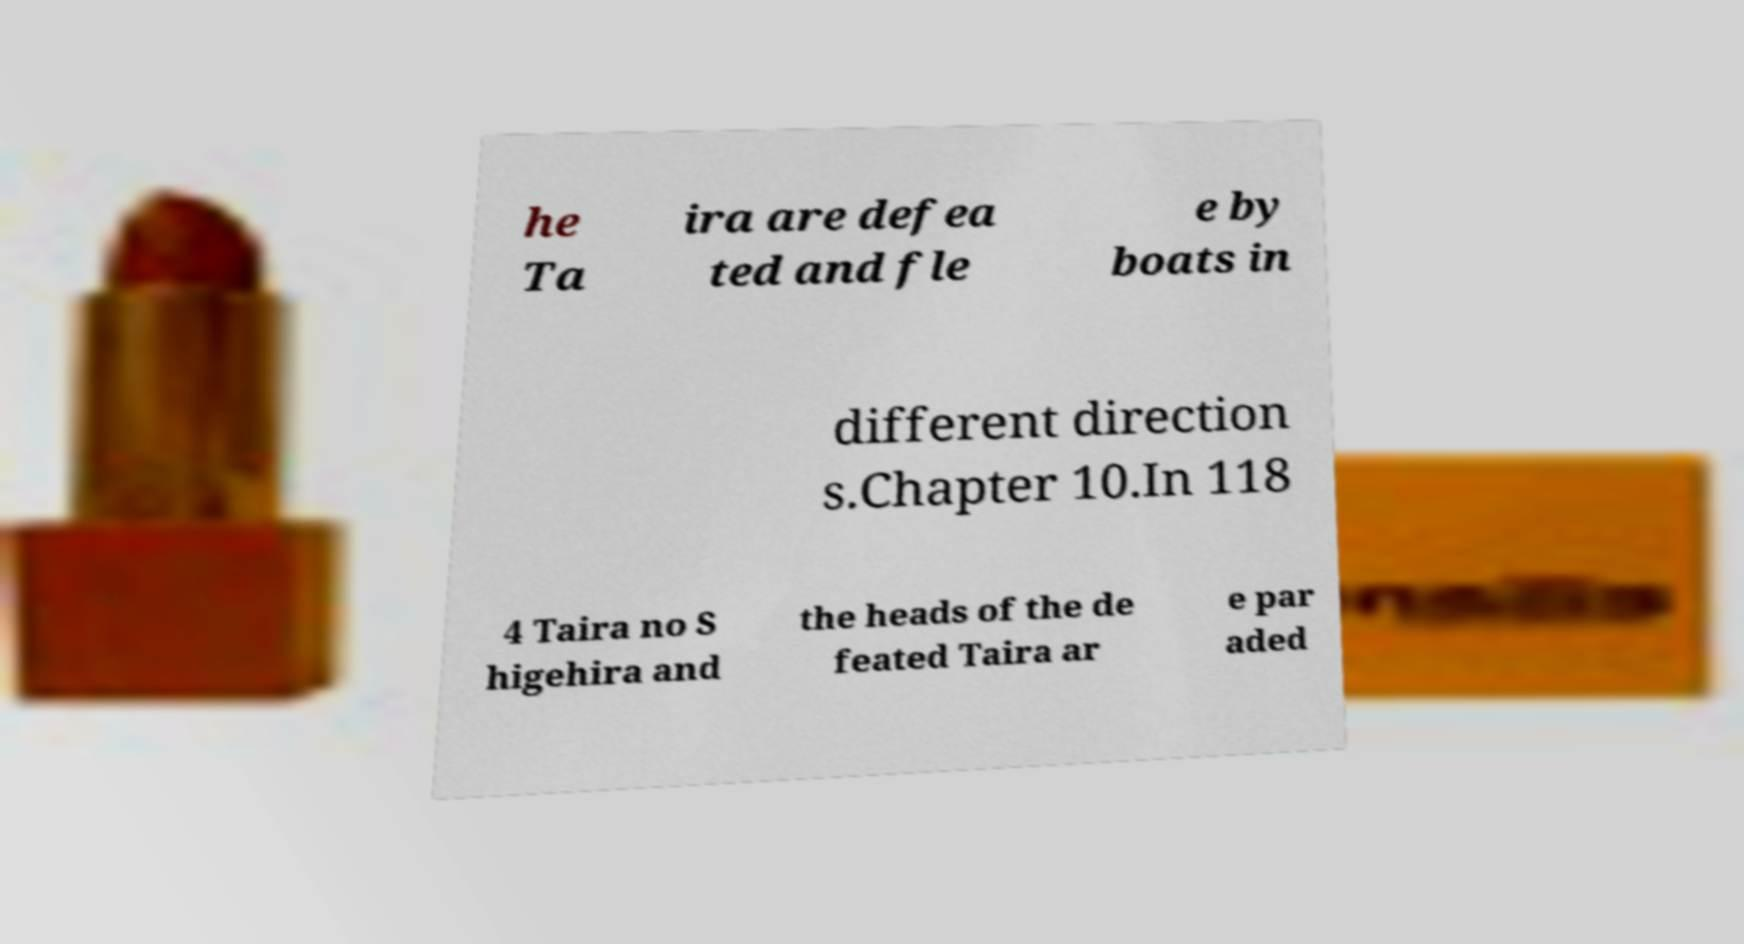For documentation purposes, I need the text within this image transcribed. Could you provide that? he Ta ira are defea ted and fle e by boats in different direction s.Chapter 10.In 118 4 Taira no S higehira and the heads of the de feated Taira ar e par aded 